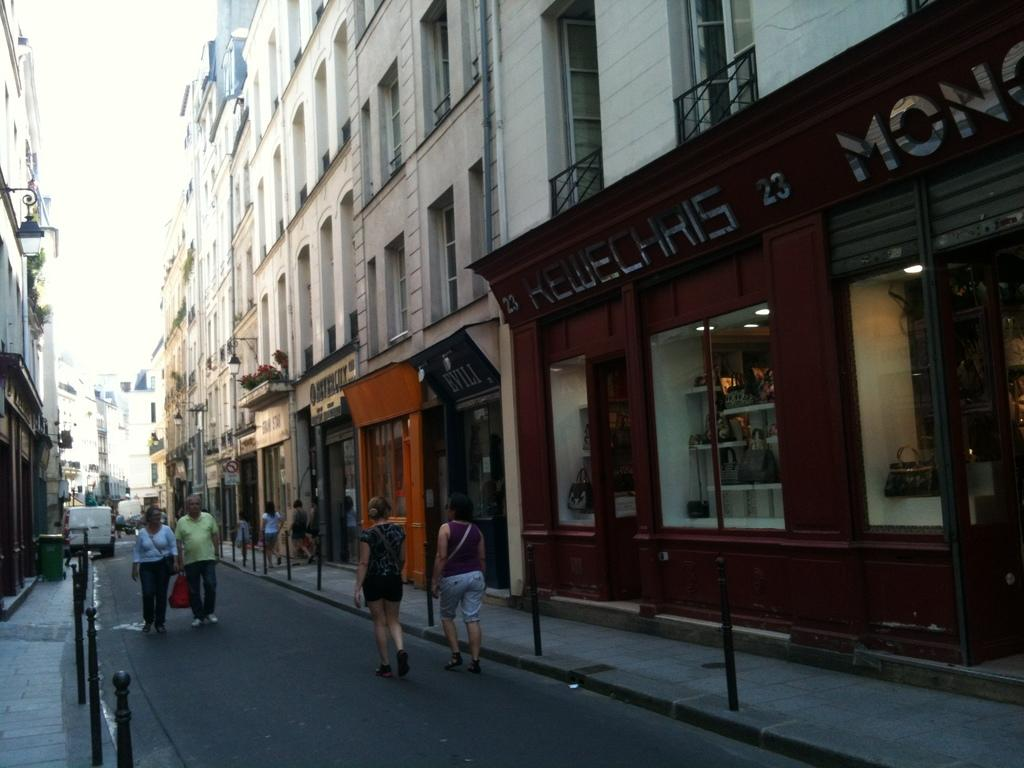What type of structures can be seen in the image? There are buildings in the image. What else can be seen in the image besides buildings? There are poles, people, a vehicle on the road, and the sky visible in the background. Can you describe the vehicle in the image? The vehicle is on the road in the image, but its specific type is not mentioned. What is visible in the background of the image? The sky is visible in the background of the image. Who is the owner of the grain depicted in the image? There is no grain present in the image, so it is not possible to determine the owner. 